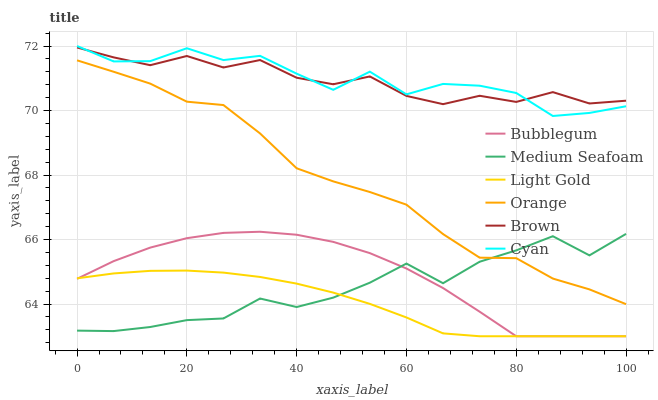Does Light Gold have the minimum area under the curve?
Answer yes or no. Yes. Does Cyan have the maximum area under the curve?
Answer yes or no. Yes. Does Bubblegum have the minimum area under the curve?
Answer yes or no. No. Does Bubblegum have the maximum area under the curve?
Answer yes or no. No. Is Light Gold the smoothest?
Answer yes or no. Yes. Is Cyan the roughest?
Answer yes or no. Yes. Is Bubblegum the smoothest?
Answer yes or no. No. Is Bubblegum the roughest?
Answer yes or no. No. Does Bubblegum have the lowest value?
Answer yes or no. Yes. Does Orange have the lowest value?
Answer yes or no. No. Does Cyan have the highest value?
Answer yes or no. Yes. Does Bubblegum have the highest value?
Answer yes or no. No. Is Medium Seafoam less than Brown?
Answer yes or no. Yes. Is Brown greater than Light Gold?
Answer yes or no. Yes. Does Light Gold intersect Bubblegum?
Answer yes or no. Yes. Is Light Gold less than Bubblegum?
Answer yes or no. No. Is Light Gold greater than Bubblegum?
Answer yes or no. No. Does Medium Seafoam intersect Brown?
Answer yes or no. No. 